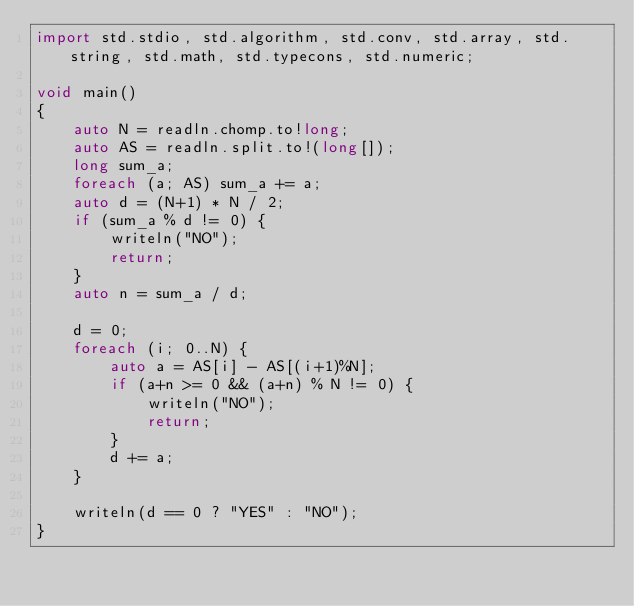Convert code to text. <code><loc_0><loc_0><loc_500><loc_500><_D_>import std.stdio, std.algorithm, std.conv, std.array, std.string, std.math, std.typecons, std.numeric;

void main()
{
    auto N = readln.chomp.to!long;
    auto AS = readln.split.to!(long[]);
    long sum_a;
    foreach (a; AS) sum_a += a;
    auto d = (N+1) * N / 2;
    if (sum_a % d != 0) {
        writeln("NO");
        return;
    }
    auto n = sum_a / d;

    d = 0;
    foreach (i; 0..N) {
        auto a = AS[i] - AS[(i+1)%N];
        if (a+n >= 0 && (a+n) % N != 0) {
            writeln("NO");
            return;
        }
        d += a;
    }
    
    writeln(d == 0 ? "YES" : "NO");
}
</code> 